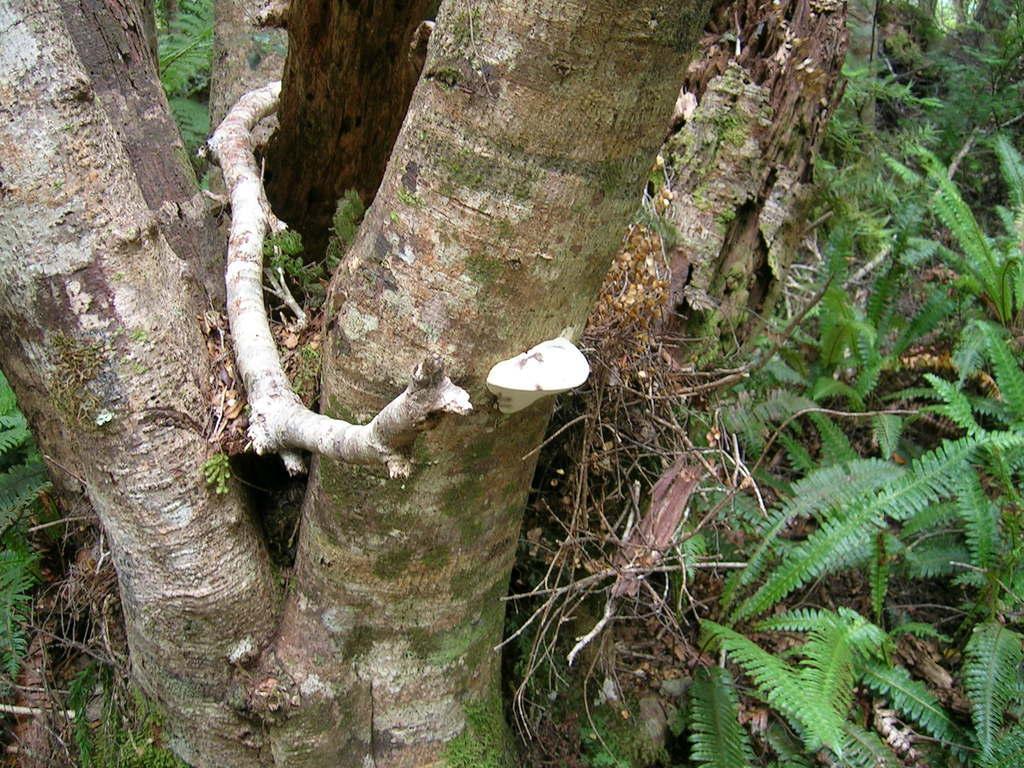Describe this image in one or two sentences. In this picture there are dry leaves, stems, twigs, the roots of a tree and the trunk of a tree. 